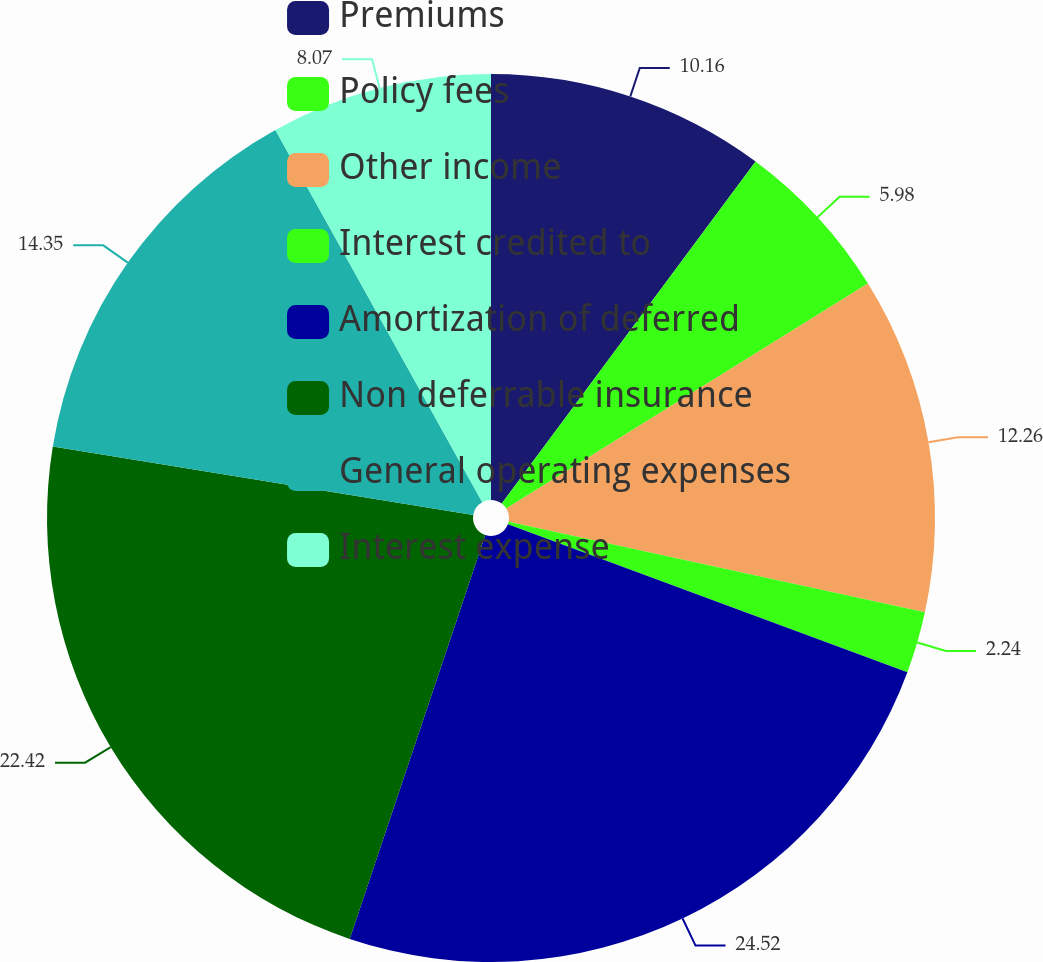Convert chart. <chart><loc_0><loc_0><loc_500><loc_500><pie_chart><fcel>Premiums<fcel>Policy fees<fcel>Other income<fcel>Interest credited to<fcel>Amortization of deferred<fcel>Non deferrable insurance<fcel>General operating expenses<fcel>Interest expense<nl><fcel>10.16%<fcel>5.98%<fcel>12.26%<fcel>2.24%<fcel>24.51%<fcel>22.42%<fcel>14.35%<fcel>8.07%<nl></chart> 